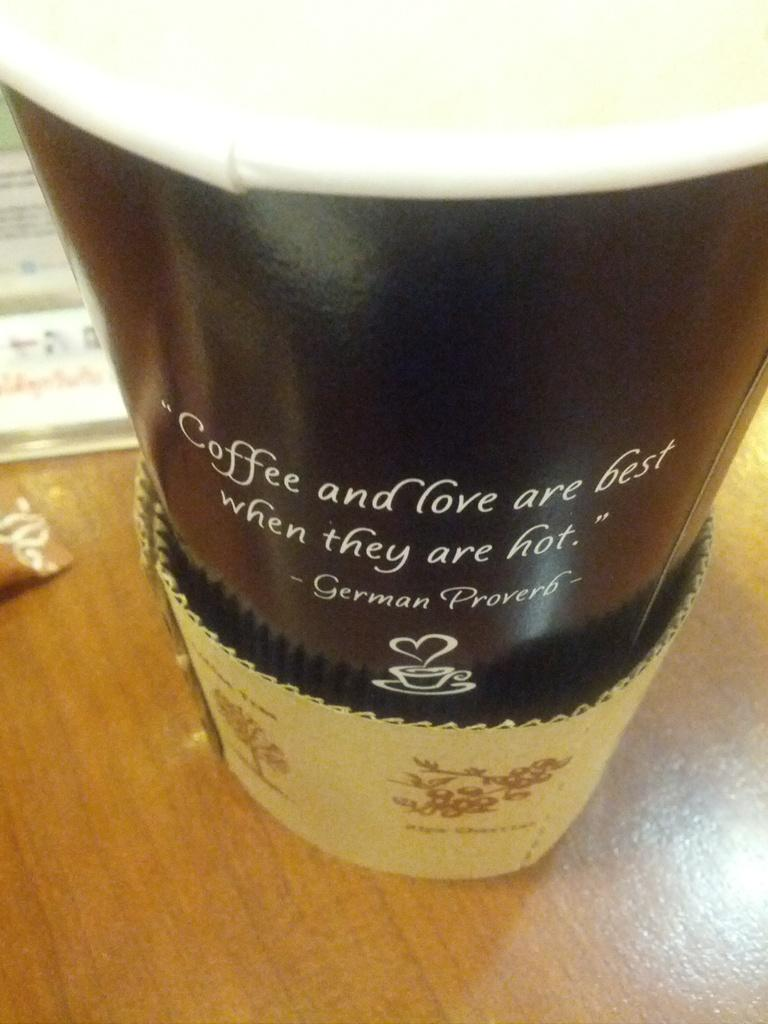<image>
Write a terse but informative summary of the picture. A cup of coffee with a German proverb written on the side. 